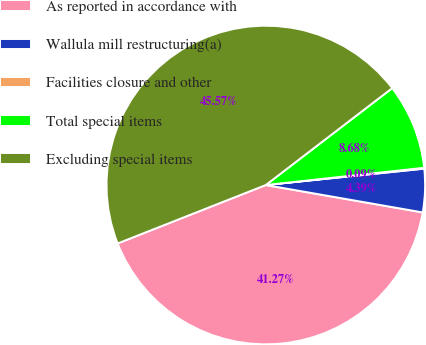Convert chart. <chart><loc_0><loc_0><loc_500><loc_500><pie_chart><fcel>As reported in accordance with<fcel>Wallula mill restructuring(a)<fcel>Facilities closure and other<fcel>Total special items<fcel>Excluding special items<nl><fcel>41.27%<fcel>4.39%<fcel>0.09%<fcel>8.68%<fcel>45.57%<nl></chart> 